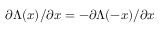<formula> <loc_0><loc_0><loc_500><loc_500>\partial \Lambda ( x ) / \partial x = - \partial \Lambda ( - x ) / \partial x</formula> 